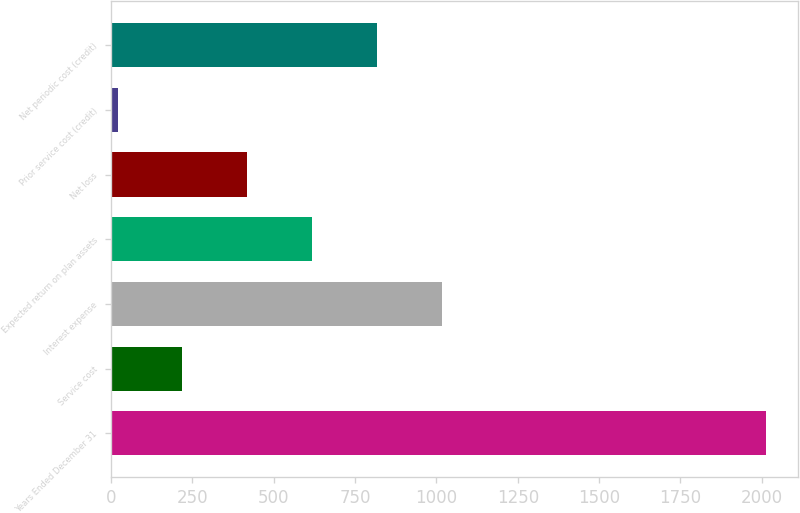<chart> <loc_0><loc_0><loc_500><loc_500><bar_chart><fcel>Years Ended December 31<fcel>Service cost<fcel>Interest expense<fcel>Expected return on plan assets<fcel>Net loss<fcel>Prior service cost (credit)<fcel>Net periodic cost (credit)<nl><fcel>2012<fcel>219.2<fcel>1016<fcel>617.6<fcel>418.4<fcel>20<fcel>816.8<nl></chart> 